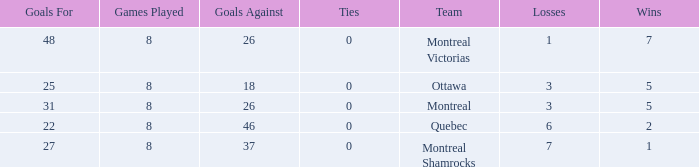How many losses did the team with 22 goals for andmore than 8 games played have? 0.0. 